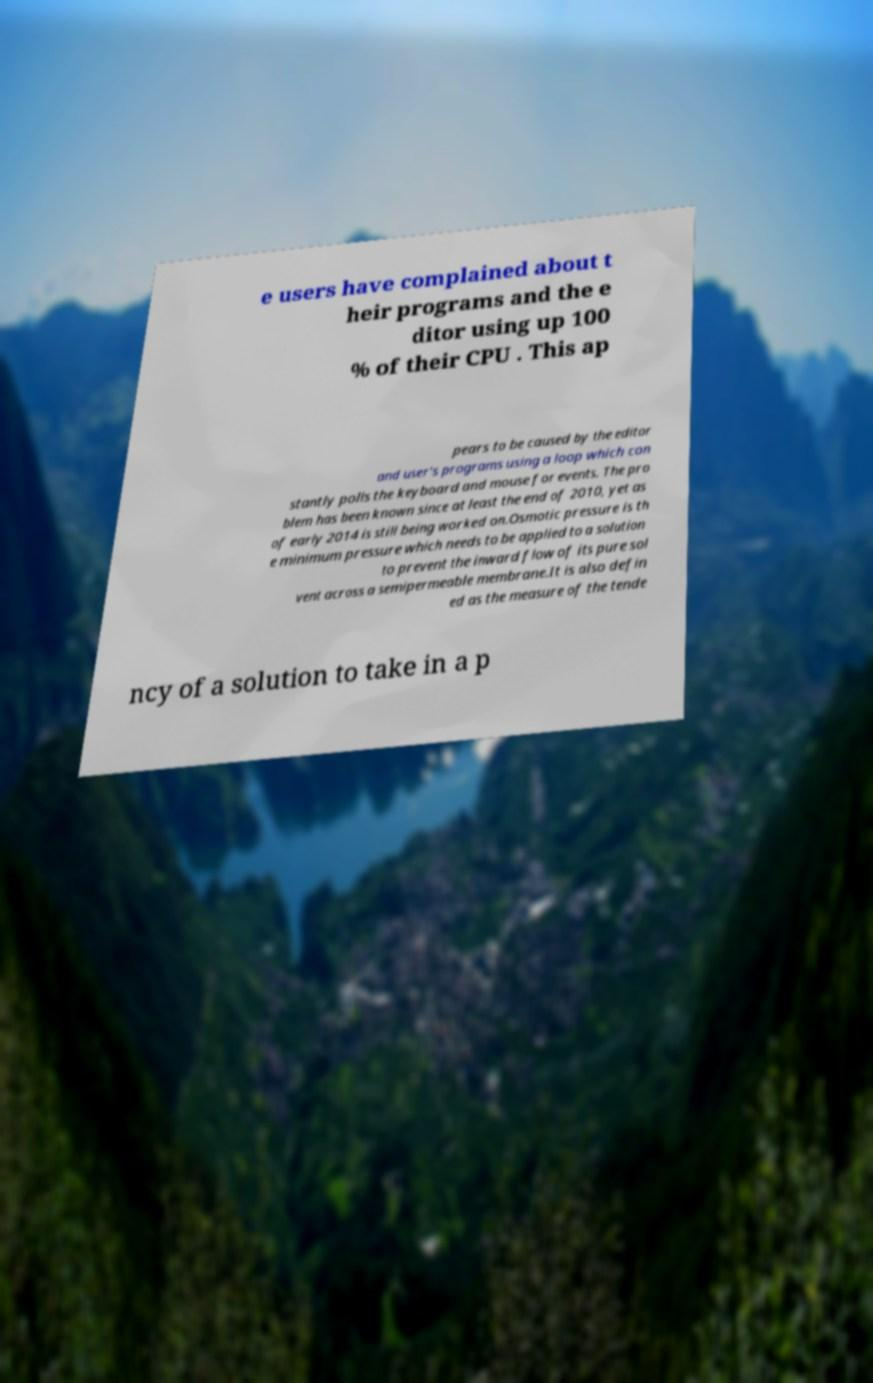For documentation purposes, I need the text within this image transcribed. Could you provide that? e users have complained about t heir programs and the e ditor using up 100 % of their CPU . This ap pears to be caused by the editor and user's programs using a loop which con stantly polls the keyboard and mouse for events. The pro blem has been known since at least the end of 2010, yet as of early 2014 is still being worked on.Osmotic pressure is th e minimum pressure which needs to be applied to a solution to prevent the inward flow of its pure sol vent across a semipermeable membrane.It is also defin ed as the measure of the tende ncy of a solution to take in a p 